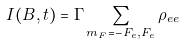Convert formula to latex. <formula><loc_0><loc_0><loc_500><loc_500>I ( B , t ) = \Gamma \sum _ { m _ { F } = - F _ { e } , F _ { e } } \rho _ { e e }</formula> 